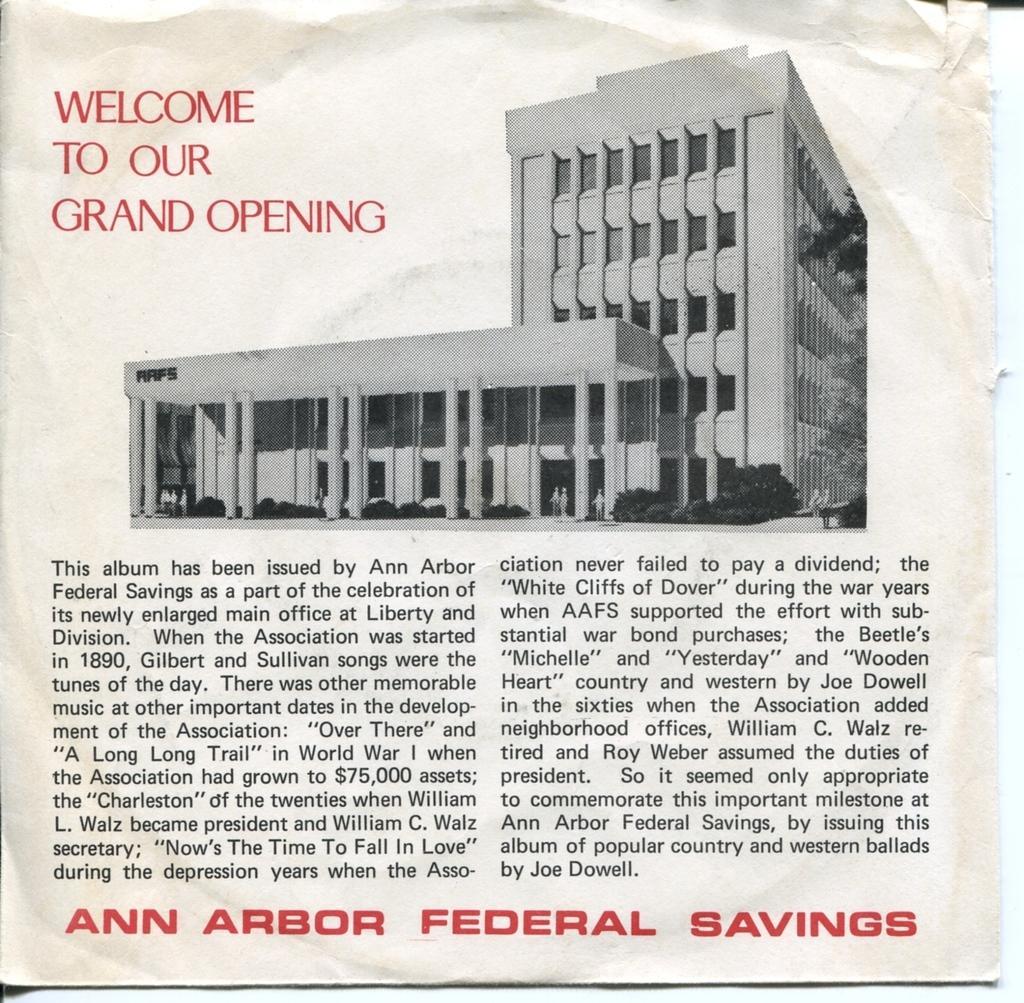Can you describe this image briefly? In this picture I can observe a picture of a building in the paper. There is some text in the paper which is in black and red color. 